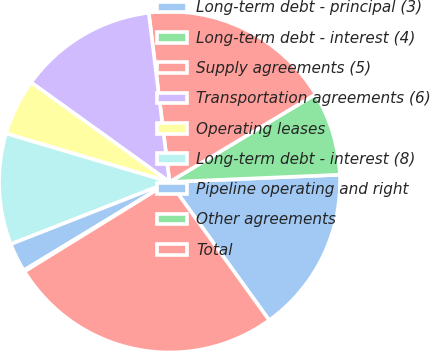Convert chart to OTSL. <chart><loc_0><loc_0><loc_500><loc_500><pie_chart><fcel>Long-term debt - principal (3)<fcel>Long-term debt - interest (4)<fcel>Supply agreements (5)<fcel>Transportation agreements (6)<fcel>Operating leases<fcel>Long-term debt - interest (8)<fcel>Pipeline operating and right<fcel>Other agreements<fcel>Total<nl><fcel>15.73%<fcel>7.93%<fcel>18.33%<fcel>13.13%<fcel>5.33%<fcel>10.53%<fcel>2.73%<fcel>0.13%<fcel>26.13%<nl></chart> 